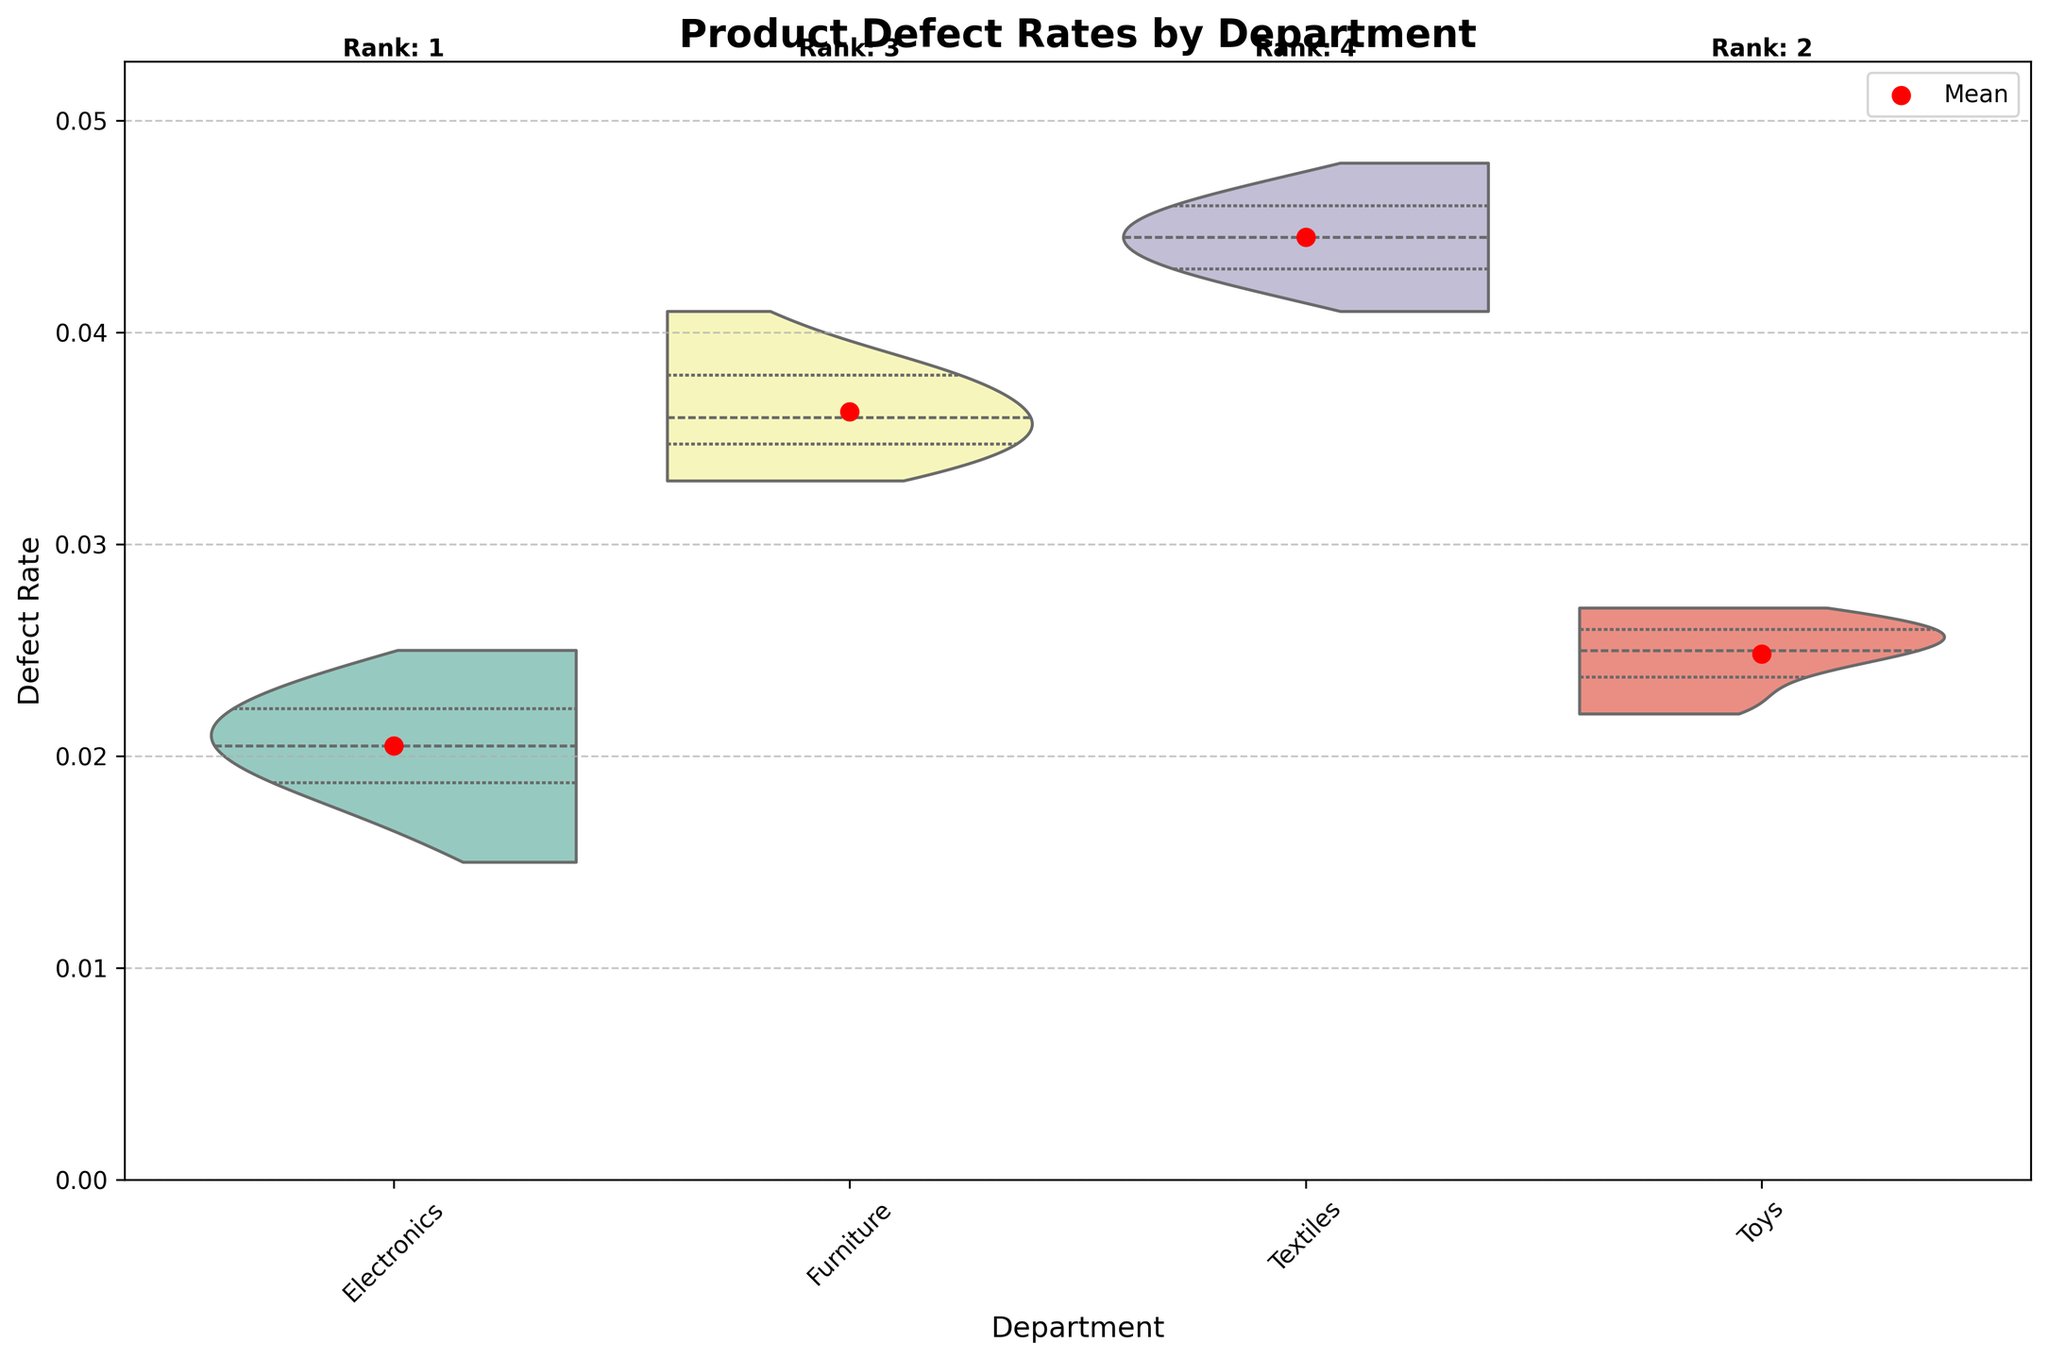What is the title of the plot? The title of the plot is displayed at the top center of the figure in bold letters. It reads 'Product Defect Rates by Department'.
Answer: Product Defect Rates by Department How many departments are represented in the plot? The x-axis of the plot shows the labels for each department. By counting them, we can see that there are four departments: Electronics, Furniture, Textiles, and Toys.
Answer: 4 What is the range of defect rates displayed on the y-axis? The y-axis has a range that starts from 0 and goes up to a value slightly above the maximum defect rate present in the data, which reaches approximately 0.053 (considering the max rate * 1.1 for ylim).
Answer: 0 to 0.053 Which department has the highest mean defect rate? There is a red point representing the mean defect rate for each department. By visually inspecting the position of these points, the highest one is for the Textiles department.
Answer: Textiles How are the distributions of defect rates for each department shown? The distributions are represented by violin plots, which combine a box plot and density plot. Each department has a split violin that shows the distribution and quartiles of the defect rates.
Answer: Split violins What department has the lowest median defect rate and how can you tell? The median defect rate for each department is represented by the white dot within the violin plot. The lowest median dot is found in the Toys department.
Answer: Toys Rank the departments from lowest to highest mean defect rate. From the plot, we can observe and compare the heights of the red mean points. The rankings from lowest to highest mean defect rate are: Electronics, Toys, Furniture, and Textiles.
Answer: Electronics < Toys < Furniture < Textiles What is the mean defect rate for the Toys department, and where is it indicated on the plot? The mean defect rate for the Toys department is indicated by the red point within the Toys violin plot. It is marked visually at approximately 0.024.
Answer: 0.024 Which department shows the most spread or variability in defect rates? The spread or variability of defect rates is indicated by the width and overall shape of the violin plot. The Textiles department shows the widest spread, indicating the greatest variability in defect rates.
Answer: Textiles How does the defect rate variability in the Furniture department compare to that in the Electronics department? By comparing the width and shape of the violin plots for both departments, Furniture shows a wider violin plot indicating higher variability in defect rates compared to the more compact violin plot for Electronics.
Answer: Furniture has higher variability than Electronics 